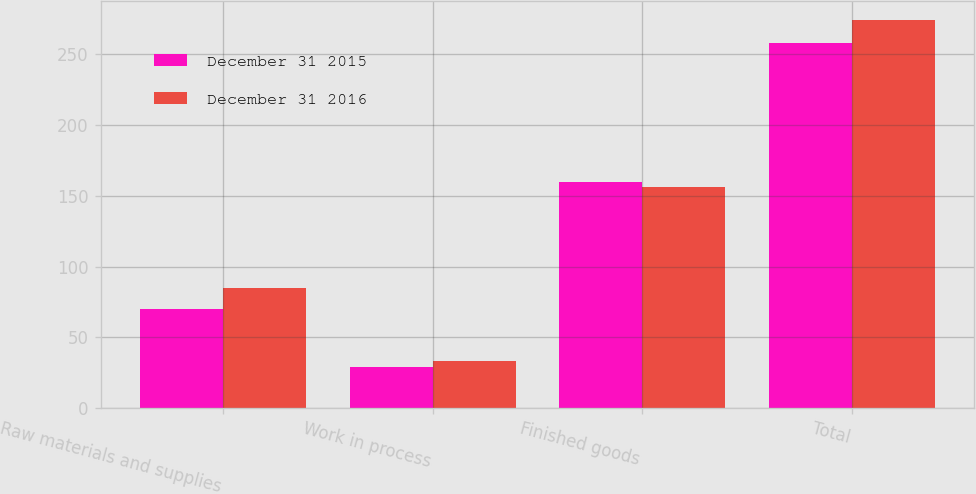<chart> <loc_0><loc_0><loc_500><loc_500><stacked_bar_chart><ecel><fcel>Raw materials and supplies<fcel>Work in process<fcel>Finished goods<fcel>Total<nl><fcel>December 31 2015<fcel>69.8<fcel>28.8<fcel>159.6<fcel>258.2<nl><fcel>December 31 2016<fcel>84.6<fcel>33.1<fcel>156.3<fcel>274<nl></chart> 